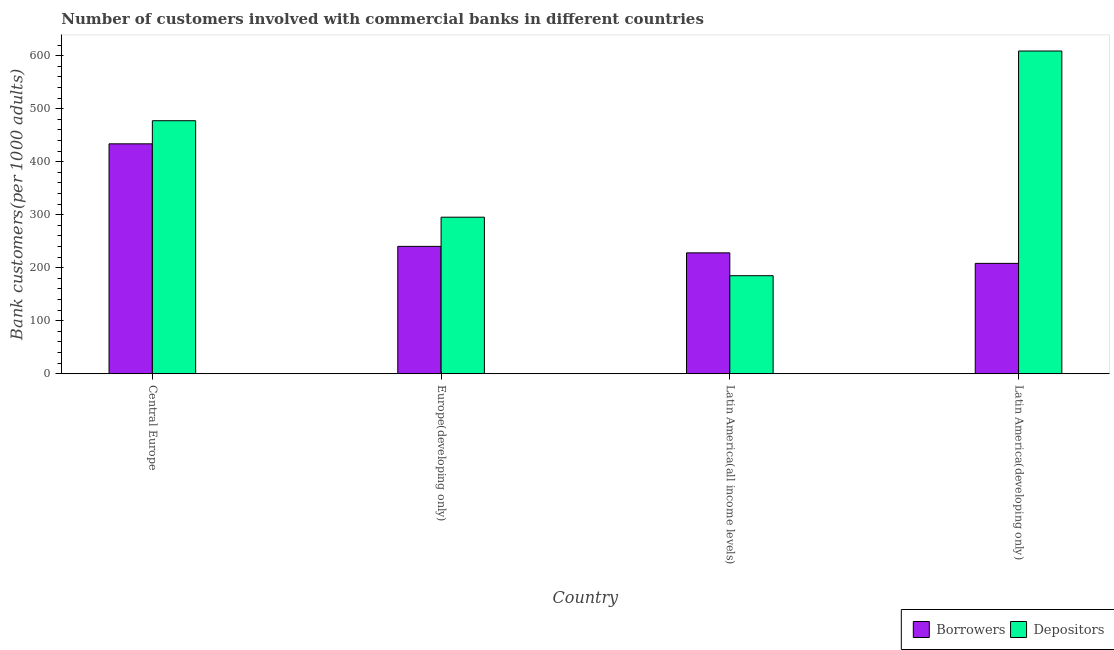Are the number of bars per tick equal to the number of legend labels?
Offer a very short reply. Yes. Are the number of bars on each tick of the X-axis equal?
Give a very brief answer. Yes. How many bars are there on the 2nd tick from the left?
Your answer should be very brief. 2. What is the label of the 3rd group of bars from the left?
Ensure brevity in your answer.  Latin America(all income levels). In how many cases, is the number of bars for a given country not equal to the number of legend labels?
Offer a terse response. 0. What is the number of depositors in Central Europe?
Keep it short and to the point. 477.2. Across all countries, what is the maximum number of borrowers?
Make the answer very short. 433.59. Across all countries, what is the minimum number of depositors?
Make the answer very short. 184.88. In which country was the number of depositors maximum?
Give a very brief answer. Latin America(developing only). In which country was the number of depositors minimum?
Your answer should be compact. Latin America(all income levels). What is the total number of depositors in the graph?
Make the answer very short. 1565.98. What is the difference between the number of borrowers in Europe(developing only) and that in Latin America(all income levels)?
Your answer should be compact. 12.24. What is the difference between the number of borrowers in Latin America(developing only) and the number of depositors in Europe(developing only)?
Offer a terse response. -87.1. What is the average number of depositors per country?
Make the answer very short. 391.49. What is the difference between the number of borrowers and number of depositors in Latin America(all income levels)?
Your response must be concise. 43.12. In how many countries, is the number of depositors greater than 80 ?
Your answer should be compact. 4. What is the ratio of the number of depositors in Europe(developing only) to that in Latin America(developing only)?
Ensure brevity in your answer.  0.49. Is the difference between the number of depositors in Europe(developing only) and Latin America(all income levels) greater than the difference between the number of borrowers in Europe(developing only) and Latin America(all income levels)?
Offer a terse response. Yes. What is the difference between the highest and the second highest number of depositors?
Your answer should be very brief. 131.47. What is the difference between the highest and the lowest number of borrowers?
Offer a terse response. 225.46. In how many countries, is the number of depositors greater than the average number of depositors taken over all countries?
Keep it short and to the point. 2. What does the 2nd bar from the left in Europe(developing only) represents?
Your response must be concise. Depositors. What does the 1st bar from the right in Latin America(developing only) represents?
Give a very brief answer. Depositors. How many bars are there?
Offer a terse response. 8. What is the title of the graph?
Offer a very short reply. Number of customers involved with commercial banks in different countries. What is the label or title of the X-axis?
Your response must be concise. Country. What is the label or title of the Y-axis?
Give a very brief answer. Bank customers(per 1000 adults). What is the Bank customers(per 1000 adults) in Borrowers in Central Europe?
Keep it short and to the point. 433.59. What is the Bank customers(per 1000 adults) in Depositors in Central Europe?
Keep it short and to the point. 477.2. What is the Bank customers(per 1000 adults) in Borrowers in Europe(developing only)?
Make the answer very short. 240.23. What is the Bank customers(per 1000 adults) in Depositors in Europe(developing only)?
Provide a succinct answer. 295.23. What is the Bank customers(per 1000 adults) of Borrowers in Latin America(all income levels)?
Offer a very short reply. 228. What is the Bank customers(per 1000 adults) in Depositors in Latin America(all income levels)?
Provide a succinct answer. 184.88. What is the Bank customers(per 1000 adults) of Borrowers in Latin America(developing only)?
Your answer should be compact. 208.14. What is the Bank customers(per 1000 adults) in Depositors in Latin America(developing only)?
Your response must be concise. 608.67. Across all countries, what is the maximum Bank customers(per 1000 adults) in Borrowers?
Provide a succinct answer. 433.59. Across all countries, what is the maximum Bank customers(per 1000 adults) of Depositors?
Give a very brief answer. 608.67. Across all countries, what is the minimum Bank customers(per 1000 adults) of Borrowers?
Your answer should be very brief. 208.14. Across all countries, what is the minimum Bank customers(per 1000 adults) in Depositors?
Offer a terse response. 184.88. What is the total Bank customers(per 1000 adults) in Borrowers in the graph?
Keep it short and to the point. 1109.96. What is the total Bank customers(per 1000 adults) in Depositors in the graph?
Your answer should be very brief. 1565.98. What is the difference between the Bank customers(per 1000 adults) of Borrowers in Central Europe and that in Europe(developing only)?
Offer a terse response. 193.36. What is the difference between the Bank customers(per 1000 adults) of Depositors in Central Europe and that in Europe(developing only)?
Ensure brevity in your answer.  181.97. What is the difference between the Bank customers(per 1000 adults) in Borrowers in Central Europe and that in Latin America(all income levels)?
Offer a very short reply. 205.59. What is the difference between the Bank customers(per 1000 adults) in Depositors in Central Europe and that in Latin America(all income levels)?
Give a very brief answer. 292.32. What is the difference between the Bank customers(per 1000 adults) of Borrowers in Central Europe and that in Latin America(developing only)?
Provide a succinct answer. 225.46. What is the difference between the Bank customers(per 1000 adults) of Depositors in Central Europe and that in Latin America(developing only)?
Give a very brief answer. -131.47. What is the difference between the Bank customers(per 1000 adults) in Borrowers in Europe(developing only) and that in Latin America(all income levels)?
Provide a succinct answer. 12.24. What is the difference between the Bank customers(per 1000 adults) of Depositors in Europe(developing only) and that in Latin America(all income levels)?
Keep it short and to the point. 110.35. What is the difference between the Bank customers(per 1000 adults) in Borrowers in Europe(developing only) and that in Latin America(developing only)?
Ensure brevity in your answer.  32.1. What is the difference between the Bank customers(per 1000 adults) in Depositors in Europe(developing only) and that in Latin America(developing only)?
Your answer should be compact. -313.43. What is the difference between the Bank customers(per 1000 adults) of Borrowers in Latin America(all income levels) and that in Latin America(developing only)?
Keep it short and to the point. 19.86. What is the difference between the Bank customers(per 1000 adults) in Depositors in Latin America(all income levels) and that in Latin America(developing only)?
Your answer should be very brief. -423.79. What is the difference between the Bank customers(per 1000 adults) of Borrowers in Central Europe and the Bank customers(per 1000 adults) of Depositors in Europe(developing only)?
Provide a succinct answer. 138.36. What is the difference between the Bank customers(per 1000 adults) of Borrowers in Central Europe and the Bank customers(per 1000 adults) of Depositors in Latin America(all income levels)?
Ensure brevity in your answer.  248.71. What is the difference between the Bank customers(per 1000 adults) of Borrowers in Central Europe and the Bank customers(per 1000 adults) of Depositors in Latin America(developing only)?
Your answer should be compact. -175.08. What is the difference between the Bank customers(per 1000 adults) in Borrowers in Europe(developing only) and the Bank customers(per 1000 adults) in Depositors in Latin America(all income levels)?
Your answer should be very brief. 55.36. What is the difference between the Bank customers(per 1000 adults) of Borrowers in Europe(developing only) and the Bank customers(per 1000 adults) of Depositors in Latin America(developing only)?
Give a very brief answer. -368.43. What is the difference between the Bank customers(per 1000 adults) in Borrowers in Latin America(all income levels) and the Bank customers(per 1000 adults) in Depositors in Latin America(developing only)?
Keep it short and to the point. -380.67. What is the average Bank customers(per 1000 adults) in Borrowers per country?
Provide a short and direct response. 277.49. What is the average Bank customers(per 1000 adults) of Depositors per country?
Your response must be concise. 391.49. What is the difference between the Bank customers(per 1000 adults) in Borrowers and Bank customers(per 1000 adults) in Depositors in Central Europe?
Provide a succinct answer. -43.61. What is the difference between the Bank customers(per 1000 adults) of Borrowers and Bank customers(per 1000 adults) of Depositors in Europe(developing only)?
Provide a short and direct response. -55. What is the difference between the Bank customers(per 1000 adults) of Borrowers and Bank customers(per 1000 adults) of Depositors in Latin America(all income levels)?
Your response must be concise. 43.12. What is the difference between the Bank customers(per 1000 adults) in Borrowers and Bank customers(per 1000 adults) in Depositors in Latin America(developing only)?
Provide a succinct answer. -400.53. What is the ratio of the Bank customers(per 1000 adults) in Borrowers in Central Europe to that in Europe(developing only)?
Ensure brevity in your answer.  1.8. What is the ratio of the Bank customers(per 1000 adults) of Depositors in Central Europe to that in Europe(developing only)?
Your response must be concise. 1.62. What is the ratio of the Bank customers(per 1000 adults) in Borrowers in Central Europe to that in Latin America(all income levels)?
Keep it short and to the point. 1.9. What is the ratio of the Bank customers(per 1000 adults) in Depositors in Central Europe to that in Latin America(all income levels)?
Your response must be concise. 2.58. What is the ratio of the Bank customers(per 1000 adults) of Borrowers in Central Europe to that in Latin America(developing only)?
Your response must be concise. 2.08. What is the ratio of the Bank customers(per 1000 adults) in Depositors in Central Europe to that in Latin America(developing only)?
Give a very brief answer. 0.78. What is the ratio of the Bank customers(per 1000 adults) in Borrowers in Europe(developing only) to that in Latin America(all income levels)?
Your answer should be very brief. 1.05. What is the ratio of the Bank customers(per 1000 adults) in Depositors in Europe(developing only) to that in Latin America(all income levels)?
Offer a terse response. 1.6. What is the ratio of the Bank customers(per 1000 adults) of Borrowers in Europe(developing only) to that in Latin America(developing only)?
Your answer should be compact. 1.15. What is the ratio of the Bank customers(per 1000 adults) in Depositors in Europe(developing only) to that in Latin America(developing only)?
Provide a short and direct response. 0.48. What is the ratio of the Bank customers(per 1000 adults) of Borrowers in Latin America(all income levels) to that in Latin America(developing only)?
Ensure brevity in your answer.  1.1. What is the ratio of the Bank customers(per 1000 adults) in Depositors in Latin America(all income levels) to that in Latin America(developing only)?
Provide a succinct answer. 0.3. What is the difference between the highest and the second highest Bank customers(per 1000 adults) in Borrowers?
Provide a short and direct response. 193.36. What is the difference between the highest and the second highest Bank customers(per 1000 adults) of Depositors?
Ensure brevity in your answer.  131.47. What is the difference between the highest and the lowest Bank customers(per 1000 adults) in Borrowers?
Your answer should be compact. 225.46. What is the difference between the highest and the lowest Bank customers(per 1000 adults) of Depositors?
Give a very brief answer. 423.79. 